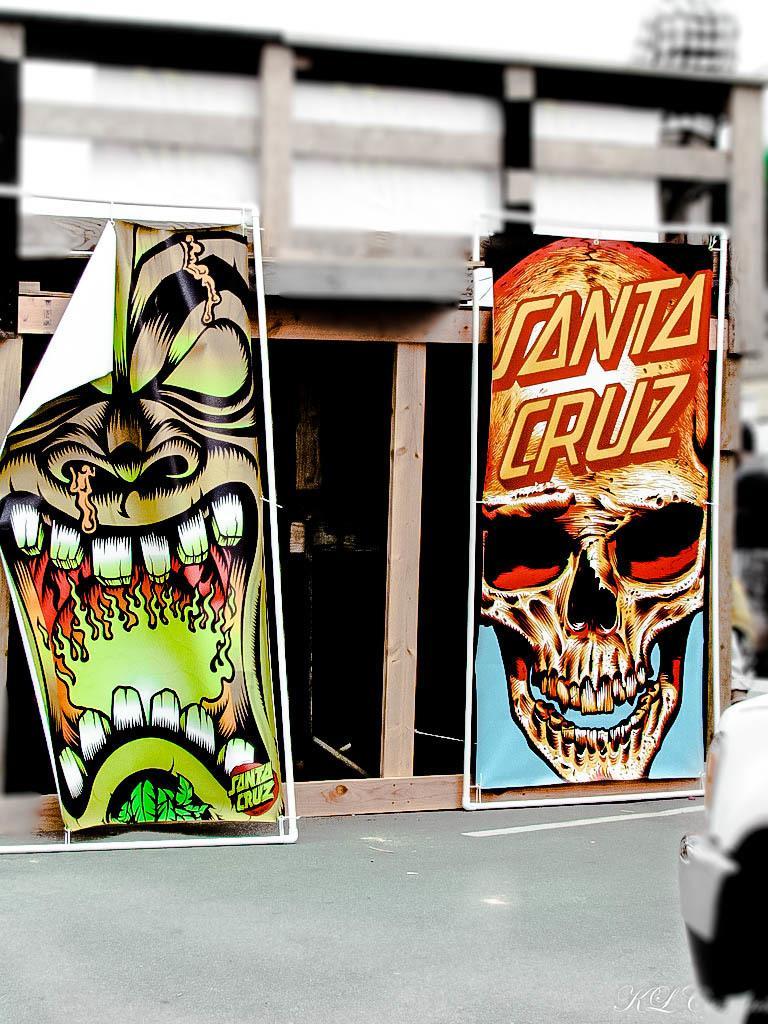Please provide a concise description of this image. In this image we can see there is a building with glass doors, behind them there are two big posters with skull images. 